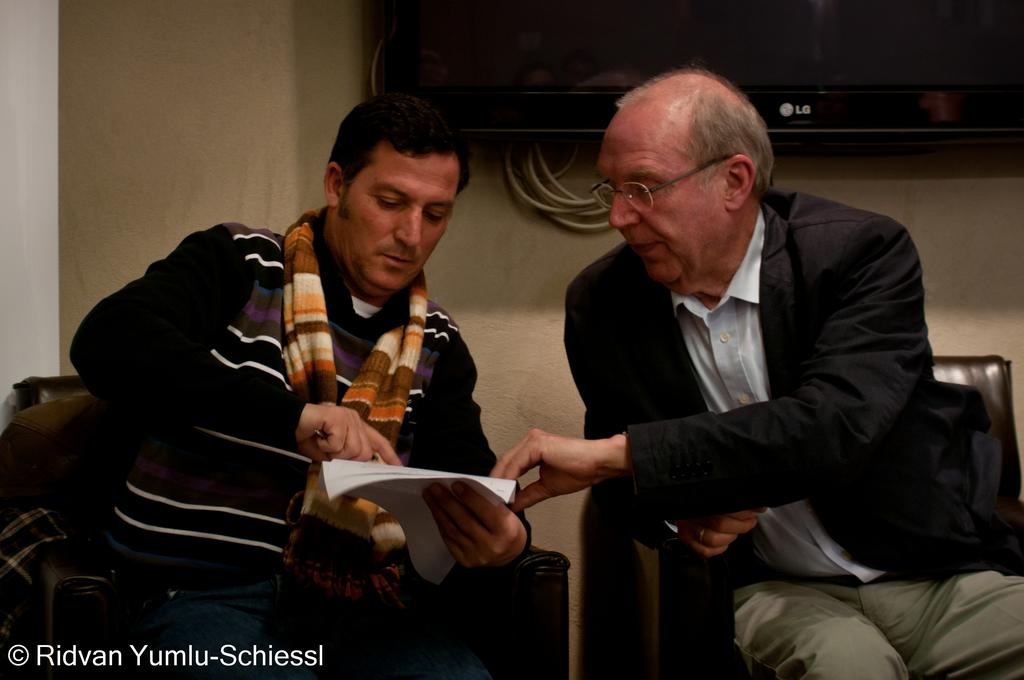How many people are in the image? There are two men in the image. What are the men doing in the image? The men are sitting on chairs. What is the person on the left holding? The person on the left is holding papers and an object in his hands. Where is the TV located in the image? The TV is in the background of the image and mounted on the wall. What type of song is the person on the right singing in the image? There is no indication in the image that the person on the right is singing, so it cannot be determined from the picture. 